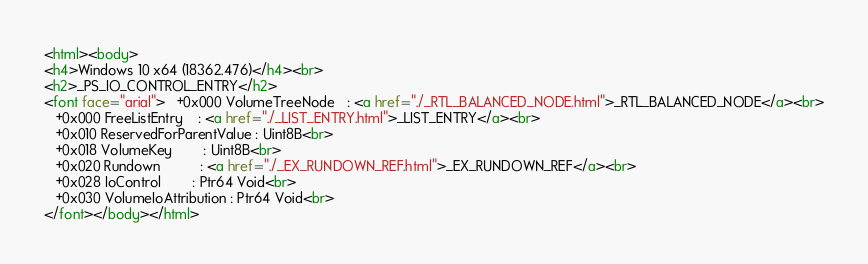Convert code to text. <code><loc_0><loc_0><loc_500><loc_500><_HTML_><html><body>
<h4>Windows 10 x64 (18362.476)</h4><br>
<h2>_PS_IO_CONTROL_ENTRY</h2>
<font face="arial">   +0x000 VolumeTreeNode   : <a href="./_RTL_BALANCED_NODE.html">_RTL_BALANCED_NODE</a><br>
   +0x000 FreeListEntry    : <a href="./_LIST_ENTRY.html">_LIST_ENTRY</a><br>
   +0x010 ReservedForParentValue : Uint8B<br>
   +0x018 VolumeKey        : Uint8B<br>
   +0x020 Rundown          : <a href="./_EX_RUNDOWN_REF.html">_EX_RUNDOWN_REF</a><br>
   +0x028 IoControl        : Ptr64 Void<br>
   +0x030 VolumeIoAttribution : Ptr64 Void<br>
</font></body></html></code> 